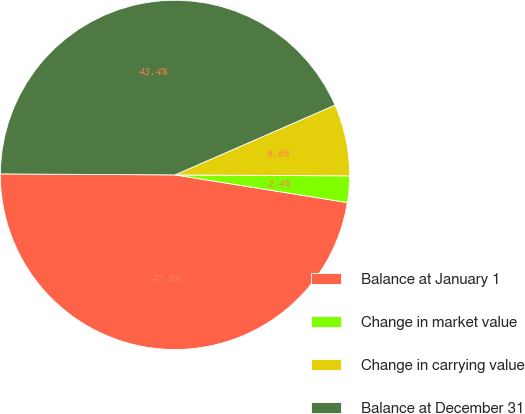<chart> <loc_0><loc_0><loc_500><loc_500><pie_chart><fcel>Balance at January 1<fcel>Change in market value<fcel>Change in carrying value<fcel>Balance at December 31<nl><fcel>47.56%<fcel>2.44%<fcel>6.64%<fcel>43.36%<nl></chart> 